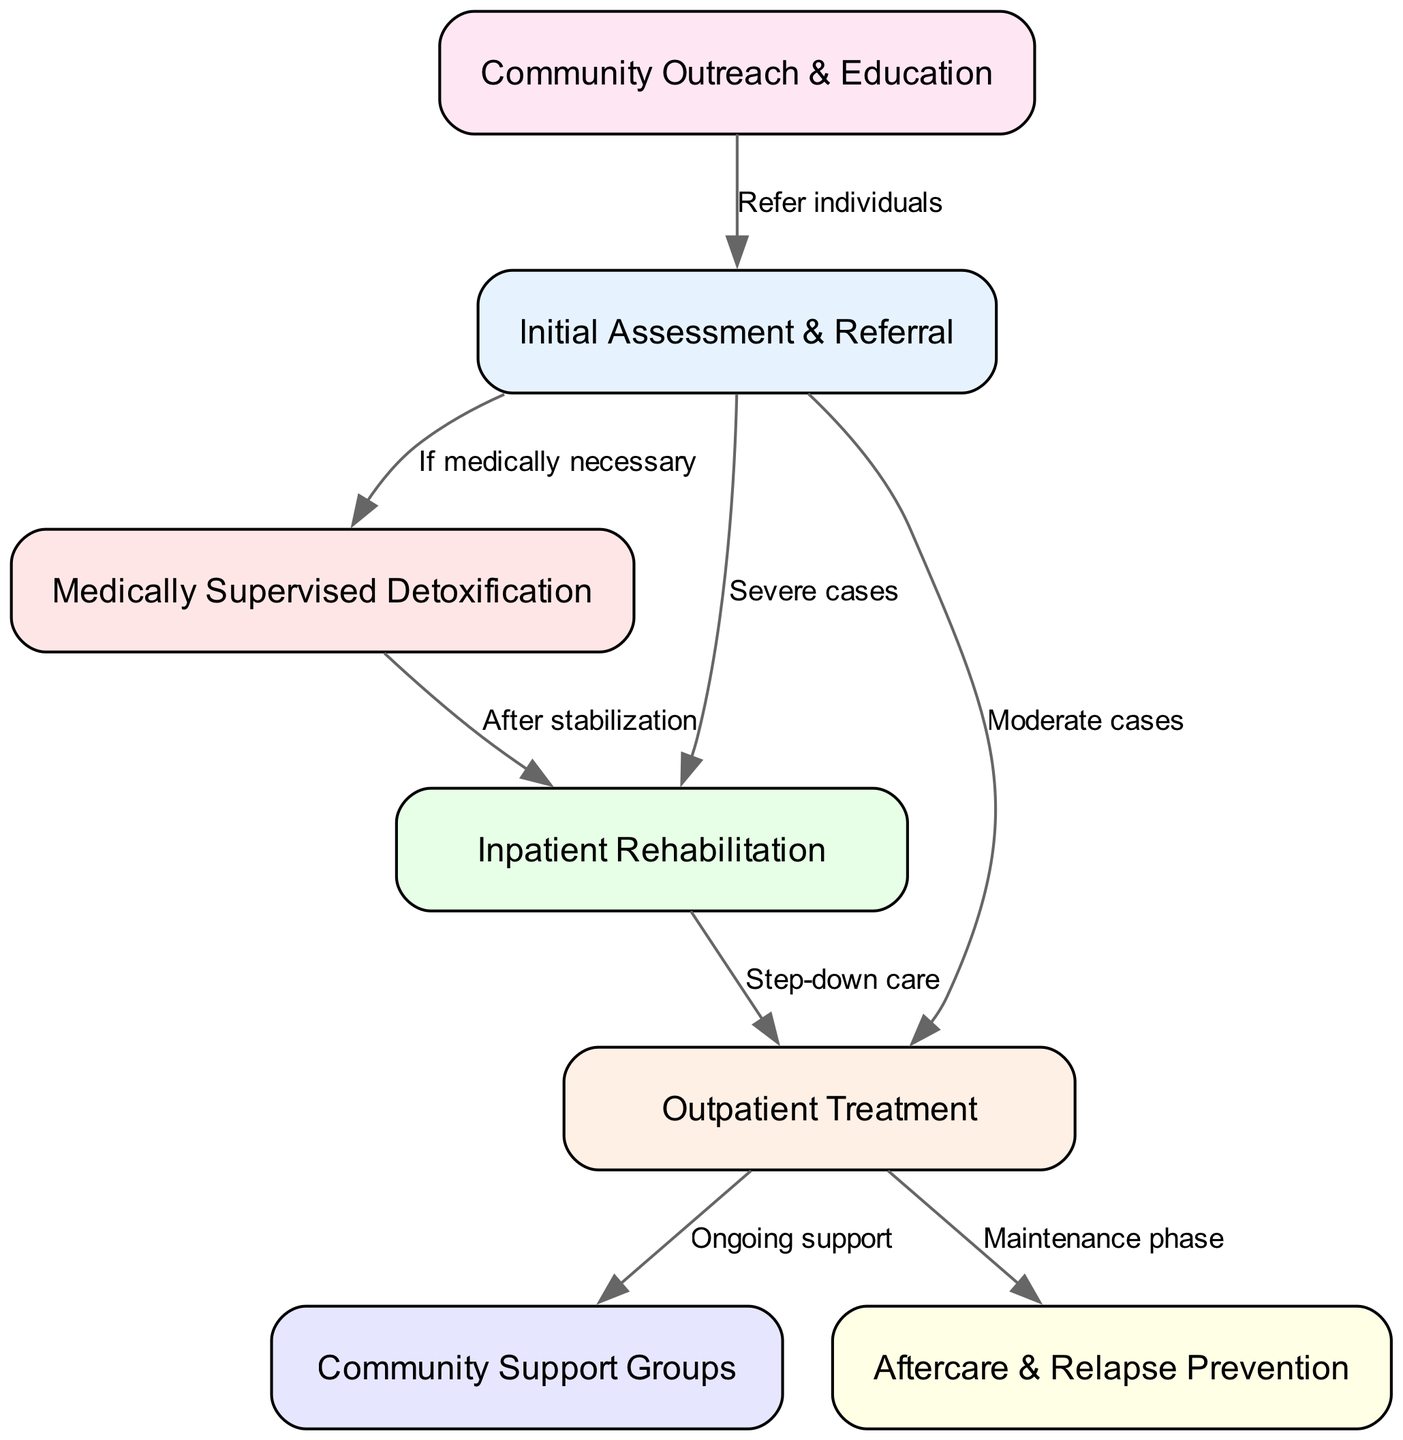What is the first step in the clinical pathway? The first step in the clinical pathway is represented by the node labeled "Initial Assessment & Referral," which is the starting point for individuals seeking substance abuse treatment.
Answer: Initial Assessment & Referral How many nodes are there in the diagram? By counting each square or rectangle representing a node in the diagram, we see there are seven distinct nodes, showing different stages of the treatment process.
Answer: 7 What action follows medically supervised detoxification? After medically supervised detoxification, the next step in the pathway is labeled "Inpatient Rehabilitation," which indicates a progression towards more intensive treatment after detoxification.
Answer: Inpatient Rehabilitation What type of cases require inpatient rehabilitation? The diagram indicates that inpatient rehabilitation is necessary for "Severe cases," as shown by the specific label leading from the "Initial Assessment & Referral" node to "Inpatient Rehabilitation."
Answer: Severe cases Which step comes after outpatient treatment? Following outpatient treatment, individuals are directed towards "Community Support Groups" and "Aftercare & Relapse Prevention," indicating ongoing support and strategies to prevent relapse.
Answer: Community Support Groups and Aftercare & Relapse Prevention What is the purpose of community outreach? Community outreach serves to "Refer individuals," connecting those who require help with the initial step in the treatment pathway, thus playing a critical role in accessibility to care.
Answer: Refer individuals What is the connection between outpatient treatment and support groups? The relationship shows that "Outpatient Treatment" leads to "Community Support Groups" with an ongoing support label, indicating that after outpatient treatment, individuals are encouraged to join support groups for additional assistance.
Answer: Ongoing support How is detoxification connected to inpatient rehabilitation? Detoxification is linked to inpatient rehabilitation with the label "After stabilization," meaning after the detox process, individuals may require further inpatient care before other treatment options.
Answer: After stabilization What happens after step-down care? Following step-down care from inpatient rehabilitation, the next step is outpatient treatment, indicating a gradual transition to less intensive treatment as recovery progresses.
Answer: Outpatient Treatment 